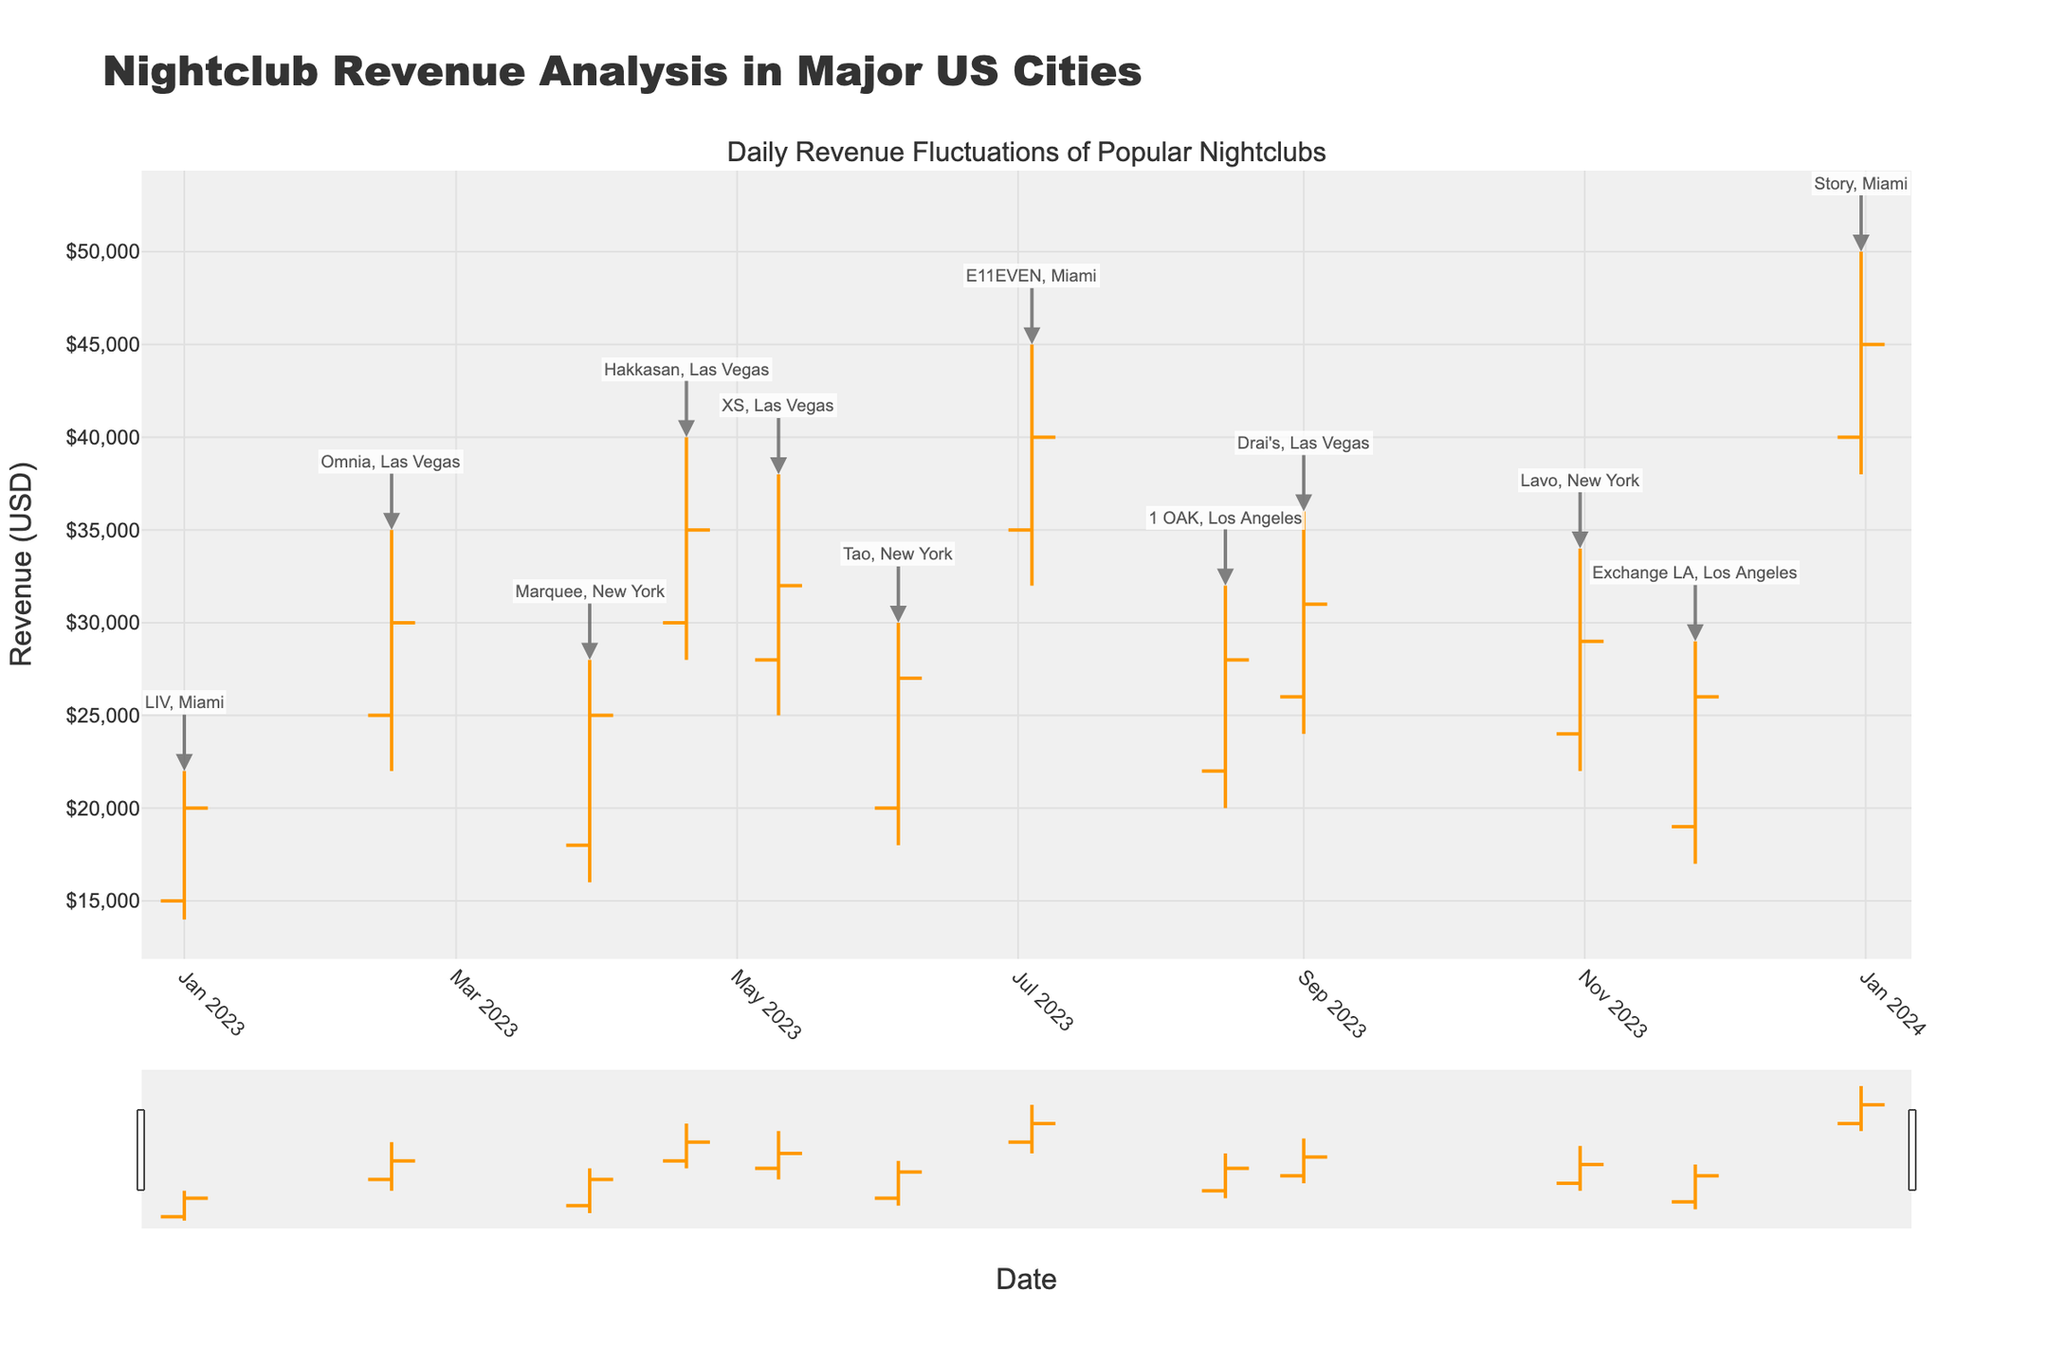what is the title of the figure? The title is displayed in large text at the top of the figure, and it summarizes the content of the chart.
Answer: Nightclub Revenue Analysis in Major US Cities how many data points are represented in the figure? Each data point corresponds to a date and is represented by an OHLC (Open, High, Low, Close) bar. By counting the individual OHLC bars, we determine the number of data points.
Answer: 12 which club has the highest closing revenue? Identify the highest closing value among all the OHLC bars and note the associated club from the annotation.
Answer: Story, Miami what is the revenue range for E11EVEN in Miami? The revenue range for an individual club is the difference between the highest and lowest values for that club. For E11EVEN, identify the high and low values from its OHLC bar.
Answer: $12,000 how does the closing revenue of Hakkasan in Las Vegas compare to that of XS in Las Vegas? Locate the closing revenues for both Hakkasan and XS. Compare these two values to see which is higher.
Answer: Hakkasan's closing revenue ($35,000) is higher than XS's ($32,000) what is the average closing revenue across all clubs? Sum up all the closing revenues of the clubs and divide by the number of clubs (12 in this case) to get the average closing revenue.
Answer: $30,400 which month showed the highest revenue for any club, and what was the club? Locate the club with the highest high value and note the corresponding month from the OHLC bar's date.
Answer: December, Story, Miami how does the revenue volatility of 1 OAK in Los Angeles compare to that of LIV in Miami? Revenue volatility can be seen as the range between high and low values. For both 1 OAK and LIV, compare these ranges (High - Low) to see which is more volatile.
Answer: LIV ($8,000) is less volatile than 1 OAK ($12,000) how many clubs have a closing revenue of more than $30,000? Count the number of clubs whose closing revenue value is greater than $30,000.
Answer: 6 which city had the highest cumulative revenue (sum of closing values) over the year? Sum the closing revenues for clubs in each city. Compare to find which city has the highest total closing revenue.
Answer: Las Vegas 